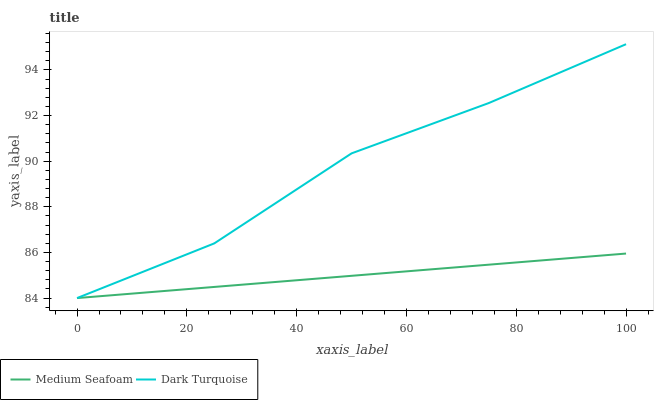Does Medium Seafoam have the minimum area under the curve?
Answer yes or no. Yes. Does Dark Turquoise have the maximum area under the curve?
Answer yes or no. Yes. Does Medium Seafoam have the maximum area under the curve?
Answer yes or no. No. Is Medium Seafoam the smoothest?
Answer yes or no. Yes. Is Dark Turquoise the roughest?
Answer yes or no. Yes. Is Medium Seafoam the roughest?
Answer yes or no. No. Does Dark Turquoise have the lowest value?
Answer yes or no. Yes. Does Dark Turquoise have the highest value?
Answer yes or no. Yes. Does Medium Seafoam have the highest value?
Answer yes or no. No. Does Medium Seafoam intersect Dark Turquoise?
Answer yes or no. Yes. Is Medium Seafoam less than Dark Turquoise?
Answer yes or no. No. Is Medium Seafoam greater than Dark Turquoise?
Answer yes or no. No. 